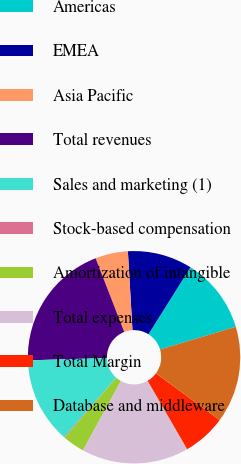Convert chart. <chart><loc_0><loc_0><loc_500><loc_500><pie_chart><fcel>Americas<fcel>EMEA<fcel>Asia Pacific<fcel>Total revenues<fcel>Sales and marketing (1)<fcel>Stock-based compensation<fcel>Amortization of intangible<fcel>Total expenses<fcel>Total Margin<fcel>Database and middleware<nl><fcel>11.46%<fcel>9.84%<fcel>4.97%<fcel>19.57%<fcel>13.08%<fcel>0.11%<fcel>3.35%<fcel>16.33%<fcel>6.59%<fcel>14.7%<nl></chart> 